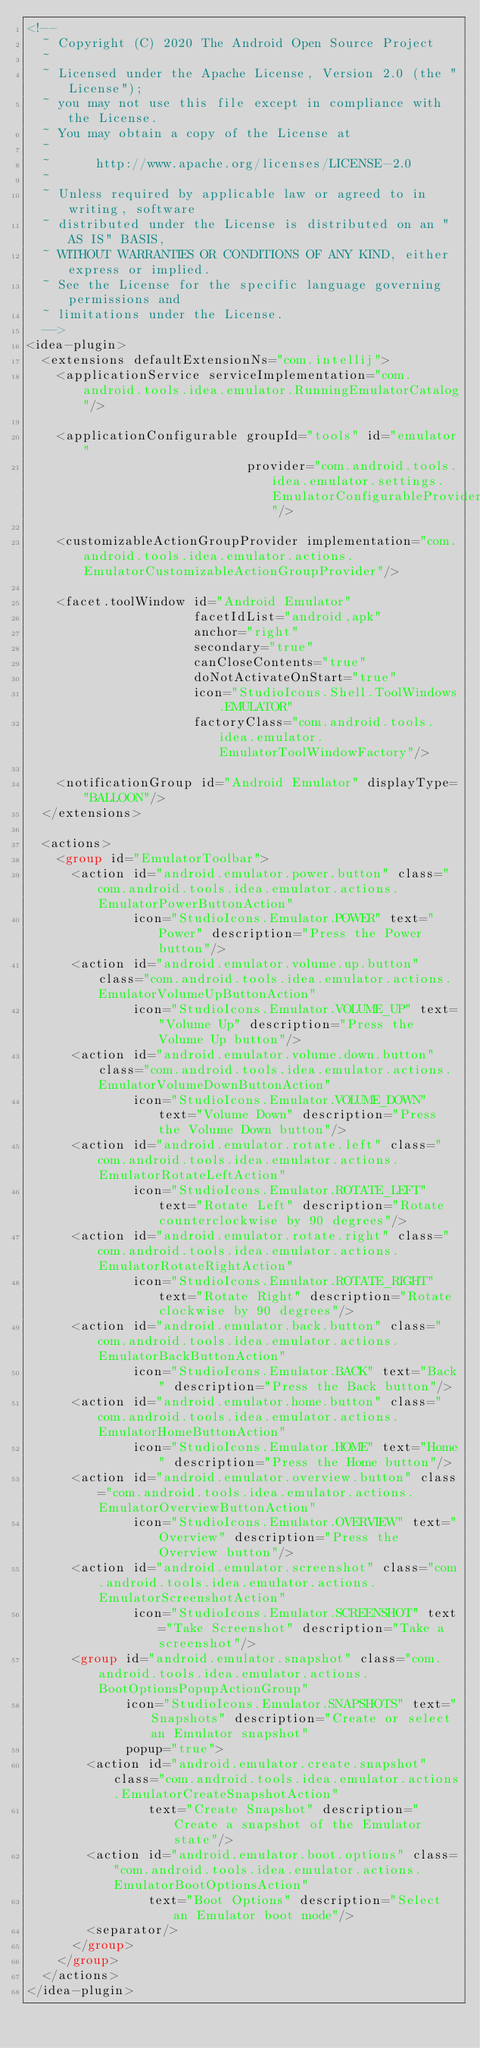Convert code to text. <code><loc_0><loc_0><loc_500><loc_500><_XML_><!--
  ~ Copyright (C) 2020 The Android Open Source Project
  ~
  ~ Licensed under the Apache License, Version 2.0 (the "License");
  ~ you may not use this file except in compliance with the License.
  ~ You may obtain a copy of the License at
  ~
  ~      http://www.apache.org/licenses/LICENSE-2.0
  ~
  ~ Unless required by applicable law or agreed to in writing, software
  ~ distributed under the License is distributed on an "AS IS" BASIS,
  ~ WITHOUT WARRANTIES OR CONDITIONS OF ANY KIND, either express or implied.
  ~ See the License for the specific language governing permissions and
  ~ limitations under the License.
  -->
<idea-plugin>
  <extensions defaultExtensionNs="com.intellij">
    <applicationService serviceImplementation="com.android.tools.idea.emulator.RunningEmulatorCatalog"/>

    <applicationConfigurable groupId="tools" id="emulator"
                             provider="com.android.tools.idea.emulator.settings.EmulatorConfigurableProvider"/>

    <customizableActionGroupProvider implementation="com.android.tools.idea.emulator.actions.EmulatorCustomizableActionGroupProvider"/>

    <facet.toolWindow id="Android Emulator"
                      facetIdList="android,apk"
                      anchor="right"
                      secondary="true"
                      canCloseContents="true"
                      doNotActivateOnStart="true"
                      icon="StudioIcons.Shell.ToolWindows.EMULATOR"
                      factoryClass="com.android.tools.idea.emulator.EmulatorToolWindowFactory"/>

    <notificationGroup id="Android Emulator" displayType="BALLOON"/>
  </extensions>

  <actions>
    <group id="EmulatorToolbar">
      <action id="android.emulator.power.button" class="com.android.tools.idea.emulator.actions.EmulatorPowerButtonAction"
              icon="StudioIcons.Emulator.POWER" text="Power" description="Press the Power button"/>
      <action id="android.emulator.volume.up.button" class="com.android.tools.idea.emulator.actions.EmulatorVolumeUpButtonAction"
              icon="StudioIcons.Emulator.VOLUME_UP" text="Volume Up" description="Press the Volume Up button"/>
      <action id="android.emulator.volume.down.button" class="com.android.tools.idea.emulator.actions.EmulatorVolumeDownButtonAction"
              icon="StudioIcons.Emulator.VOLUME_DOWN" text="Volume Down" description="Press the Volume Down button"/>
      <action id="android.emulator.rotate.left" class="com.android.tools.idea.emulator.actions.EmulatorRotateLeftAction"
              icon="StudioIcons.Emulator.ROTATE_LEFT" text="Rotate Left" description="Rotate counterclockwise by 90 degrees"/>
      <action id="android.emulator.rotate.right" class="com.android.tools.idea.emulator.actions.EmulatorRotateRightAction"
              icon="StudioIcons.Emulator.ROTATE_RIGHT" text="Rotate Right" description="Rotate clockwise by 90 degrees"/>
      <action id="android.emulator.back.button" class="com.android.tools.idea.emulator.actions.EmulatorBackButtonAction"
              icon="StudioIcons.Emulator.BACK" text="Back" description="Press the Back button"/>
      <action id="android.emulator.home.button" class="com.android.tools.idea.emulator.actions.EmulatorHomeButtonAction"
              icon="StudioIcons.Emulator.HOME" text="Home" description="Press the Home button"/>
      <action id="android.emulator.overview.button" class="com.android.tools.idea.emulator.actions.EmulatorOverviewButtonAction"
              icon="StudioIcons.Emulator.OVERVIEW" text="Overview" description="Press the Overview button"/>
      <action id="android.emulator.screenshot" class="com.android.tools.idea.emulator.actions.EmulatorScreenshotAction"
              icon="StudioIcons.Emulator.SCREENSHOT" text="Take Screenshot" description="Take a screenshot"/>
      <group id="android.emulator.snapshot" class="com.android.tools.idea.emulator.actions.BootOptionsPopupActionGroup"
             icon="StudioIcons.Emulator.SNAPSHOTS" text="Snapshots" description="Create or select an Emulator snapshot"
             popup="true">
        <action id="android.emulator.create.snapshot" class="com.android.tools.idea.emulator.actions.EmulatorCreateSnapshotAction"
                text="Create Snapshot" description="Create a snapshot of the Emulator state"/>
        <action id="android.emulator.boot.options" class="com.android.tools.idea.emulator.actions.EmulatorBootOptionsAction"
                text="Boot Options" description="Select an Emulator boot mode"/>
        <separator/>
      </group>
    </group>
  </actions>
</idea-plugin></code> 